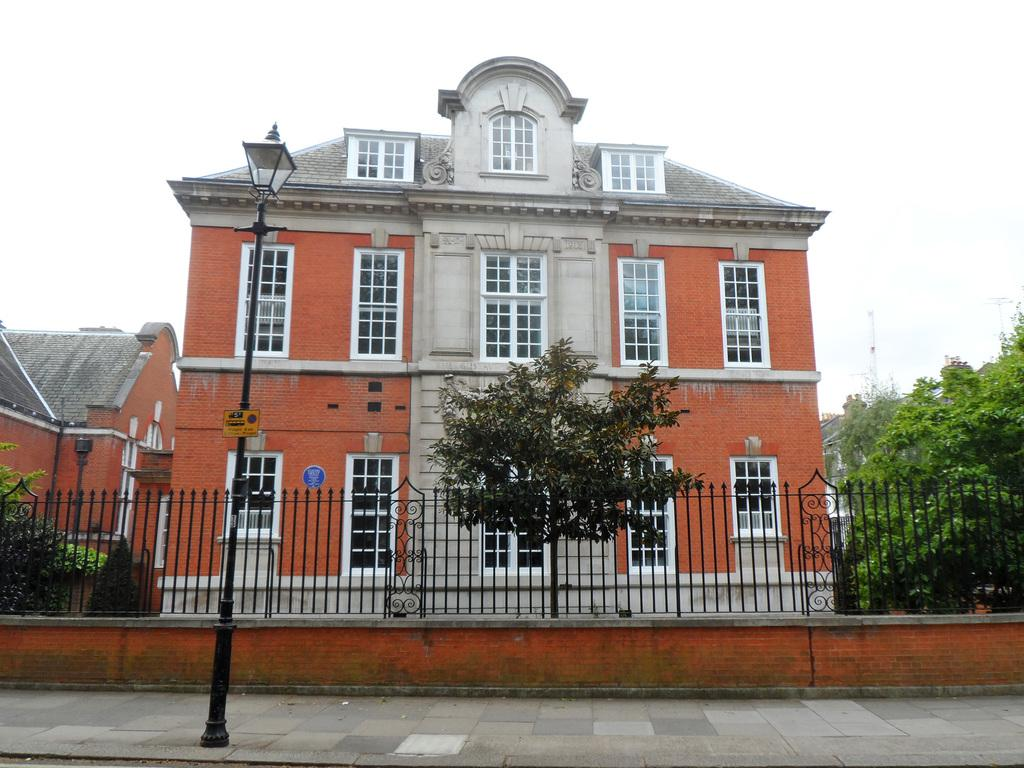What can be seen on the left side of the image? There is a pole on the side path on the left side of the image. What is located behind the pole? There is fencing behind the pole. What type of vegetation is visible in the image? There are trees visible in the image. What structures can be seen in the background of the image? There are buildings in the background of the image. What part of the natural environment is visible in the image? The sky is visible in the image. What type of milk is being poured into the alley in the image? There is no milk or alley present in the image. 